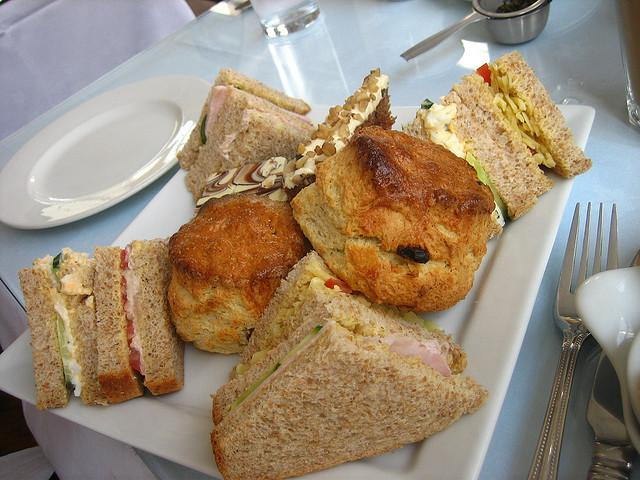What time is conducive to take the meal above?

Choices:
A) morning
B) supper
C) none
D) lunch morning 